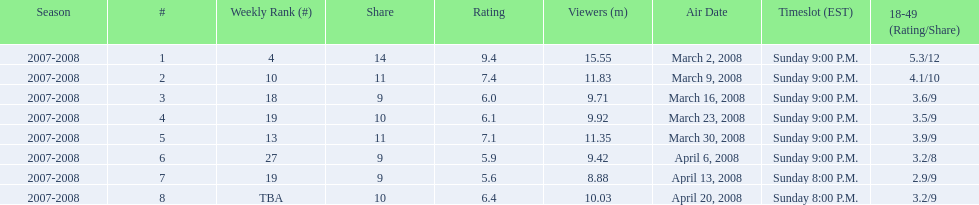How many shows had at least 10 million viewers? 4. 